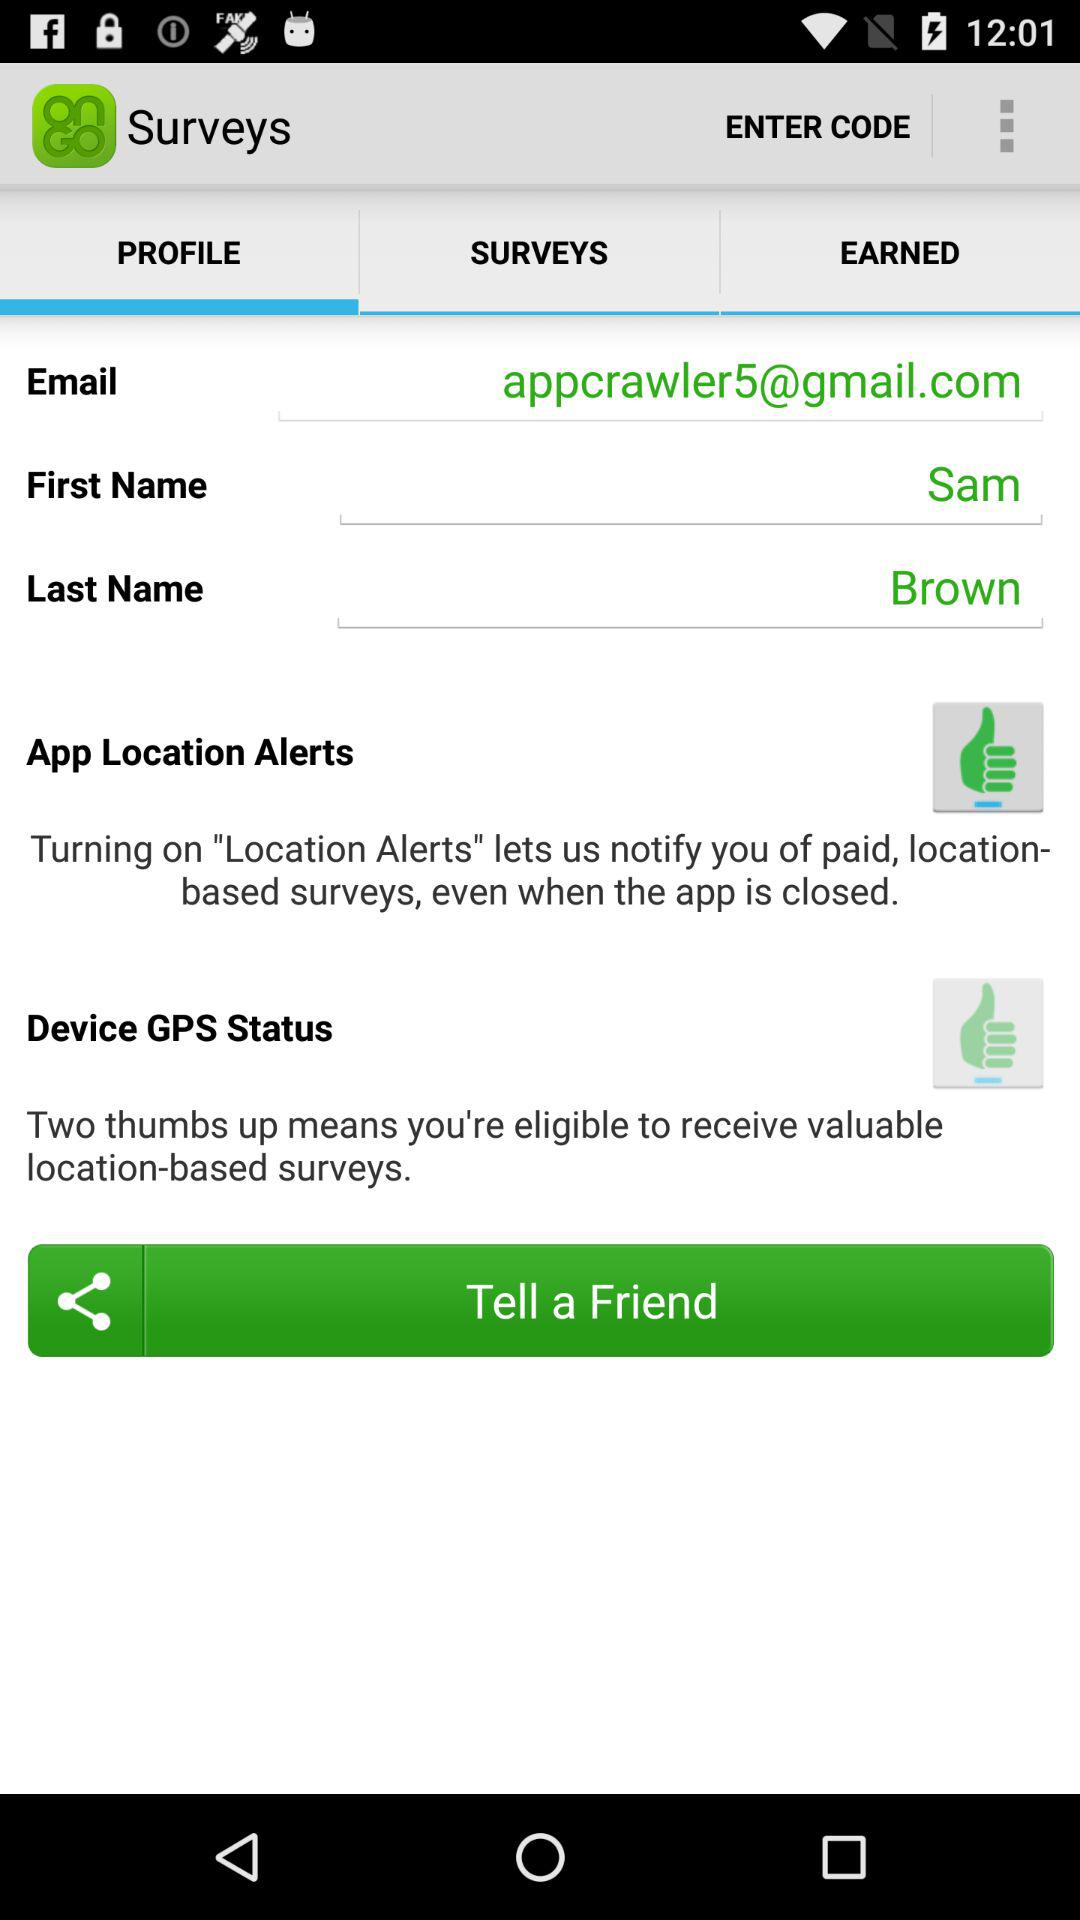What is the email address? The email address is appcrawler5@gmail.com. 